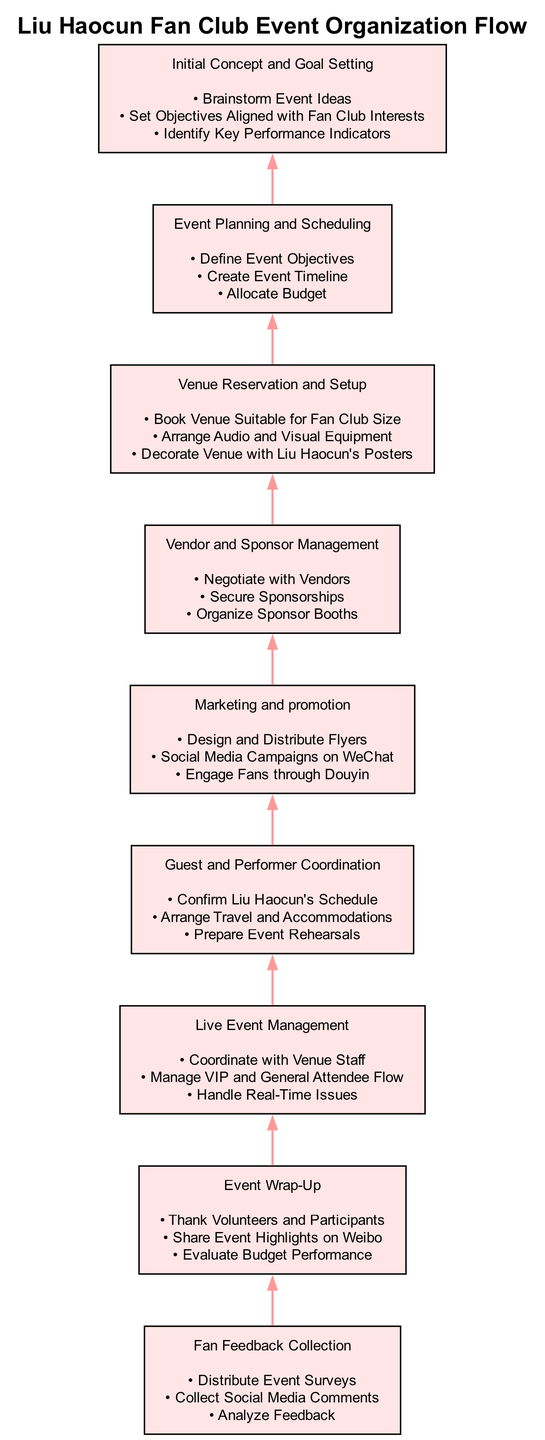What is the first step in the flow? The flow starts from the bottom with the initial concepts and goal setting. This can be identified as the first node in the diagram, which leads to the subsequent steps.
Answer: Initial Concept and Goal Setting How many actions are listed under "Marketing and promotion"? By examining the node labeled "Marketing and promotion," there are three specific actions mentioned, which can be counted directly from the diagram.
Answer: 3 Which step follows "Venue Reservation and Setup"? The flow diagram shows a direct progression upward from "Venue Reservation and Setup" to "Event Planning and Scheduling," indicating the next step in the sequence of actions.
Answer: Event Planning and Scheduling What is the main purpose of "Guest and Performer Coordination"? The actions listed under "Guest and Performer Coordination" indicate that the purpose involves confirming schedules, travel arrangements, and rehearsals for Liu Haocun, highlighting the central goal of this step.
Answer: Confirm Liu Haocun's Schedule How many nodes are there in total? Counting each node in the diagram from bottom to top results in a total of 9 distinct steps presented.
Answer: 9 What is the final step in the flow? Moving upward through the diagram reveals that the last node is "Event Wrap-Up," which serves as the concluding step of the organization process.
Answer: Event Wrap-Up Which two steps are linked by an edge directly? Looking closely at the diagram, many steps are connected by edges. However, "Vendor and Sponsor Management" and "Venue Reservation and Setup" can be identified as an example of linked nodes in this flow.
Answer: Vendor and Sponsor Management, Venue Reservation and Setup What serves as a feedback mechanism in the process? The node labeled "Fan Feedback Collection" serves as the feedback mechanism, where the organization collects opinions and comments from fans to assess the event’s success.
Answer: Fan Feedback Collection What type of actions does "Live Event Management" include? The actions detailed in the "Live Event Management" node focus on coordinating with staff, managing attendee flow, and addressing issues that arise during the event, indicating a real-time management function.
Answer: Coordinate with Venue Staff 